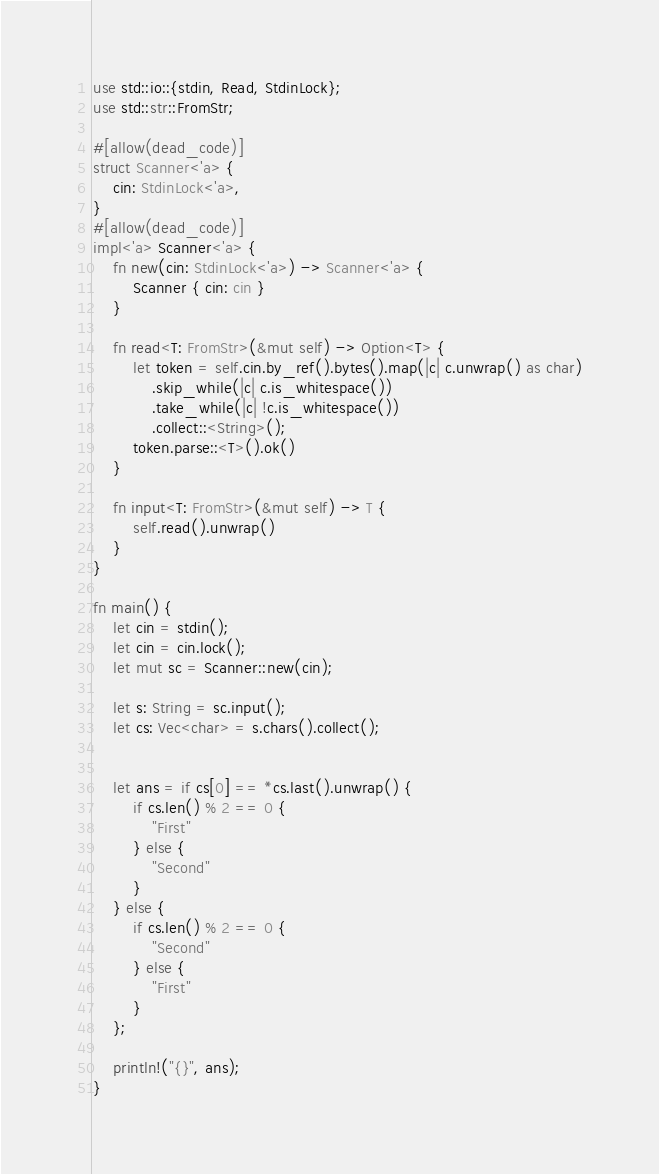<code> <loc_0><loc_0><loc_500><loc_500><_Rust_>use std::io::{stdin, Read, StdinLock};
use std::str::FromStr;

#[allow(dead_code)]
struct Scanner<'a> {
    cin: StdinLock<'a>,
}
#[allow(dead_code)]
impl<'a> Scanner<'a> {
    fn new(cin: StdinLock<'a>) -> Scanner<'a> {
        Scanner { cin: cin }
    }

    fn read<T: FromStr>(&mut self) -> Option<T> {
        let token = self.cin.by_ref().bytes().map(|c| c.unwrap() as char)
            .skip_while(|c| c.is_whitespace())
            .take_while(|c| !c.is_whitespace())
            .collect::<String>();
        token.parse::<T>().ok()
    }

    fn input<T: FromStr>(&mut self) -> T {
        self.read().unwrap()
    }
}

fn main() {
    let cin = stdin();
    let cin = cin.lock();
    let mut sc = Scanner::new(cin);

    let s: String = sc.input();
    let cs: Vec<char> = s.chars().collect();


    let ans = if cs[0] == *cs.last().unwrap() {
        if cs.len() % 2 == 0 {
            "First"
        } else {
            "Second"
        }
    } else {
        if cs.len() % 2 == 0 {
            "Second"
        } else {
            "First"
        }
    };

    println!("{}", ans);
}
</code> 